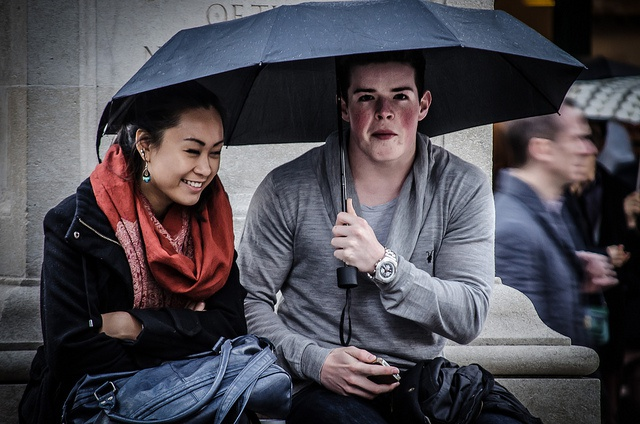Describe the objects in this image and their specific colors. I can see people in black, gray, and darkgray tones, people in black, maroon, brown, and darkgray tones, umbrella in black, gray, and darkblue tones, people in black, gray, darkgray, and navy tones, and handbag in black, gray, darkblue, and navy tones in this image. 